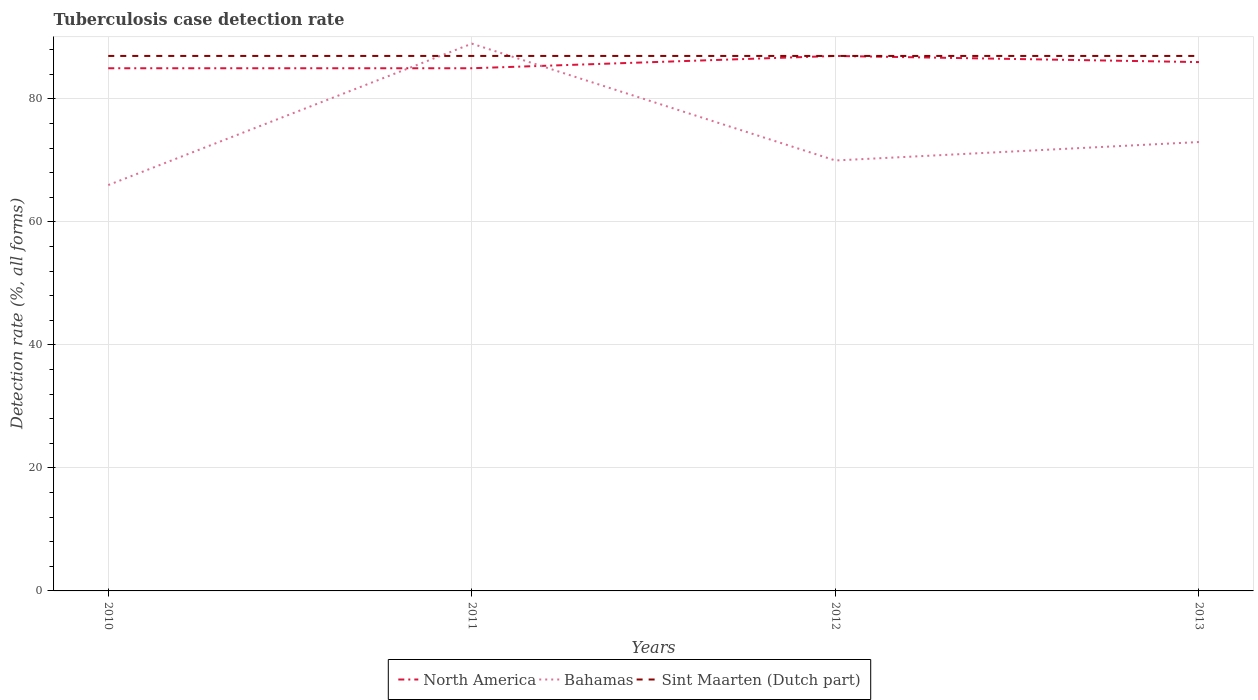Is the number of lines equal to the number of legend labels?
Give a very brief answer. Yes. What is the total tuberculosis case detection rate in in Bahamas in the graph?
Your answer should be very brief. -4. What is the difference between the highest and the lowest tuberculosis case detection rate in in Bahamas?
Keep it short and to the point. 1. Is the tuberculosis case detection rate in in Bahamas strictly greater than the tuberculosis case detection rate in in North America over the years?
Provide a short and direct response. No. How many lines are there?
Your answer should be very brief. 3. What is the difference between two consecutive major ticks on the Y-axis?
Your answer should be compact. 20. Are the values on the major ticks of Y-axis written in scientific E-notation?
Make the answer very short. No. Does the graph contain any zero values?
Your answer should be compact. No. Does the graph contain grids?
Give a very brief answer. Yes. How many legend labels are there?
Provide a short and direct response. 3. How are the legend labels stacked?
Provide a short and direct response. Horizontal. What is the title of the graph?
Keep it short and to the point. Tuberculosis case detection rate. What is the label or title of the X-axis?
Keep it short and to the point. Years. What is the label or title of the Y-axis?
Your answer should be very brief. Detection rate (%, all forms). What is the Detection rate (%, all forms) of North America in 2010?
Ensure brevity in your answer.  85. What is the Detection rate (%, all forms) in Bahamas in 2010?
Provide a short and direct response. 66. What is the Detection rate (%, all forms) of North America in 2011?
Offer a terse response. 85. What is the Detection rate (%, all forms) of Bahamas in 2011?
Provide a succinct answer. 89. What is the Detection rate (%, all forms) in Sint Maarten (Dutch part) in 2011?
Give a very brief answer. 87. What is the Detection rate (%, all forms) in North America in 2012?
Provide a short and direct response. 87. What is the Detection rate (%, all forms) of North America in 2013?
Offer a very short reply. 86. What is the Detection rate (%, all forms) of Bahamas in 2013?
Your answer should be very brief. 73. What is the Detection rate (%, all forms) of Sint Maarten (Dutch part) in 2013?
Offer a terse response. 87. Across all years, what is the maximum Detection rate (%, all forms) of North America?
Offer a very short reply. 87. Across all years, what is the maximum Detection rate (%, all forms) in Bahamas?
Keep it short and to the point. 89. Across all years, what is the minimum Detection rate (%, all forms) in North America?
Offer a terse response. 85. Across all years, what is the minimum Detection rate (%, all forms) of Sint Maarten (Dutch part)?
Provide a short and direct response. 87. What is the total Detection rate (%, all forms) in North America in the graph?
Your response must be concise. 343. What is the total Detection rate (%, all forms) of Bahamas in the graph?
Your answer should be compact. 298. What is the total Detection rate (%, all forms) in Sint Maarten (Dutch part) in the graph?
Make the answer very short. 348. What is the difference between the Detection rate (%, all forms) of North America in 2010 and that in 2011?
Make the answer very short. 0. What is the difference between the Detection rate (%, all forms) in North America in 2010 and that in 2012?
Make the answer very short. -2. What is the difference between the Detection rate (%, all forms) of Bahamas in 2010 and that in 2012?
Offer a very short reply. -4. What is the difference between the Detection rate (%, all forms) of North America in 2010 and that in 2013?
Ensure brevity in your answer.  -1. What is the difference between the Detection rate (%, all forms) in Sint Maarten (Dutch part) in 2010 and that in 2013?
Your response must be concise. 0. What is the difference between the Detection rate (%, all forms) in Bahamas in 2011 and that in 2012?
Your answer should be very brief. 19. What is the difference between the Detection rate (%, all forms) of Sint Maarten (Dutch part) in 2011 and that in 2012?
Make the answer very short. 0. What is the difference between the Detection rate (%, all forms) in North America in 2011 and that in 2013?
Make the answer very short. -1. What is the difference between the Detection rate (%, all forms) of North America in 2010 and the Detection rate (%, all forms) of Sint Maarten (Dutch part) in 2011?
Keep it short and to the point. -2. What is the difference between the Detection rate (%, all forms) of North America in 2010 and the Detection rate (%, all forms) of Bahamas in 2012?
Keep it short and to the point. 15. What is the difference between the Detection rate (%, all forms) in North America in 2010 and the Detection rate (%, all forms) in Sint Maarten (Dutch part) in 2012?
Ensure brevity in your answer.  -2. What is the difference between the Detection rate (%, all forms) in Bahamas in 2010 and the Detection rate (%, all forms) in Sint Maarten (Dutch part) in 2012?
Make the answer very short. -21. What is the difference between the Detection rate (%, all forms) of North America in 2010 and the Detection rate (%, all forms) of Sint Maarten (Dutch part) in 2013?
Your response must be concise. -2. What is the difference between the Detection rate (%, all forms) in Bahamas in 2010 and the Detection rate (%, all forms) in Sint Maarten (Dutch part) in 2013?
Provide a succinct answer. -21. What is the difference between the Detection rate (%, all forms) of North America in 2011 and the Detection rate (%, all forms) of Bahamas in 2012?
Offer a terse response. 15. What is the difference between the Detection rate (%, all forms) of North America in 2012 and the Detection rate (%, all forms) of Sint Maarten (Dutch part) in 2013?
Make the answer very short. 0. What is the average Detection rate (%, all forms) of North America per year?
Keep it short and to the point. 85.75. What is the average Detection rate (%, all forms) in Bahamas per year?
Make the answer very short. 74.5. In the year 2011, what is the difference between the Detection rate (%, all forms) in North America and Detection rate (%, all forms) in Sint Maarten (Dutch part)?
Offer a terse response. -2. What is the ratio of the Detection rate (%, all forms) in Bahamas in 2010 to that in 2011?
Ensure brevity in your answer.  0.74. What is the ratio of the Detection rate (%, all forms) in Sint Maarten (Dutch part) in 2010 to that in 2011?
Your answer should be compact. 1. What is the ratio of the Detection rate (%, all forms) in North America in 2010 to that in 2012?
Provide a short and direct response. 0.98. What is the ratio of the Detection rate (%, all forms) of Bahamas in 2010 to that in 2012?
Offer a very short reply. 0.94. What is the ratio of the Detection rate (%, all forms) in North America in 2010 to that in 2013?
Give a very brief answer. 0.99. What is the ratio of the Detection rate (%, all forms) of Bahamas in 2010 to that in 2013?
Offer a very short reply. 0.9. What is the ratio of the Detection rate (%, all forms) in Bahamas in 2011 to that in 2012?
Give a very brief answer. 1.27. What is the ratio of the Detection rate (%, all forms) of Sint Maarten (Dutch part) in 2011 to that in 2012?
Ensure brevity in your answer.  1. What is the ratio of the Detection rate (%, all forms) of North America in 2011 to that in 2013?
Provide a succinct answer. 0.99. What is the ratio of the Detection rate (%, all forms) in Bahamas in 2011 to that in 2013?
Offer a terse response. 1.22. What is the ratio of the Detection rate (%, all forms) of Sint Maarten (Dutch part) in 2011 to that in 2013?
Ensure brevity in your answer.  1. What is the ratio of the Detection rate (%, all forms) in North America in 2012 to that in 2013?
Your answer should be compact. 1.01. What is the ratio of the Detection rate (%, all forms) in Bahamas in 2012 to that in 2013?
Offer a terse response. 0.96. What is the ratio of the Detection rate (%, all forms) in Sint Maarten (Dutch part) in 2012 to that in 2013?
Provide a succinct answer. 1. What is the difference between the highest and the second highest Detection rate (%, all forms) of North America?
Offer a terse response. 1. What is the difference between the highest and the second highest Detection rate (%, all forms) of Bahamas?
Make the answer very short. 16. What is the difference between the highest and the second highest Detection rate (%, all forms) in Sint Maarten (Dutch part)?
Make the answer very short. 0. What is the difference between the highest and the lowest Detection rate (%, all forms) in Bahamas?
Give a very brief answer. 23. 